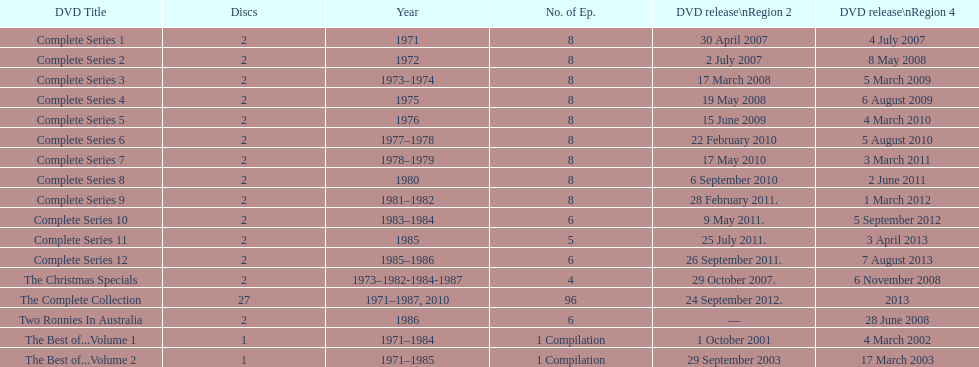True or false. the television show "the two ronnies" featured more than 10 episodes in a season. False. 